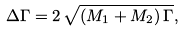<formula> <loc_0><loc_0><loc_500><loc_500>\Delta \Gamma = 2 \, \sqrt { ( M _ { 1 } + M _ { 2 } ) \, \Gamma } ,</formula> 